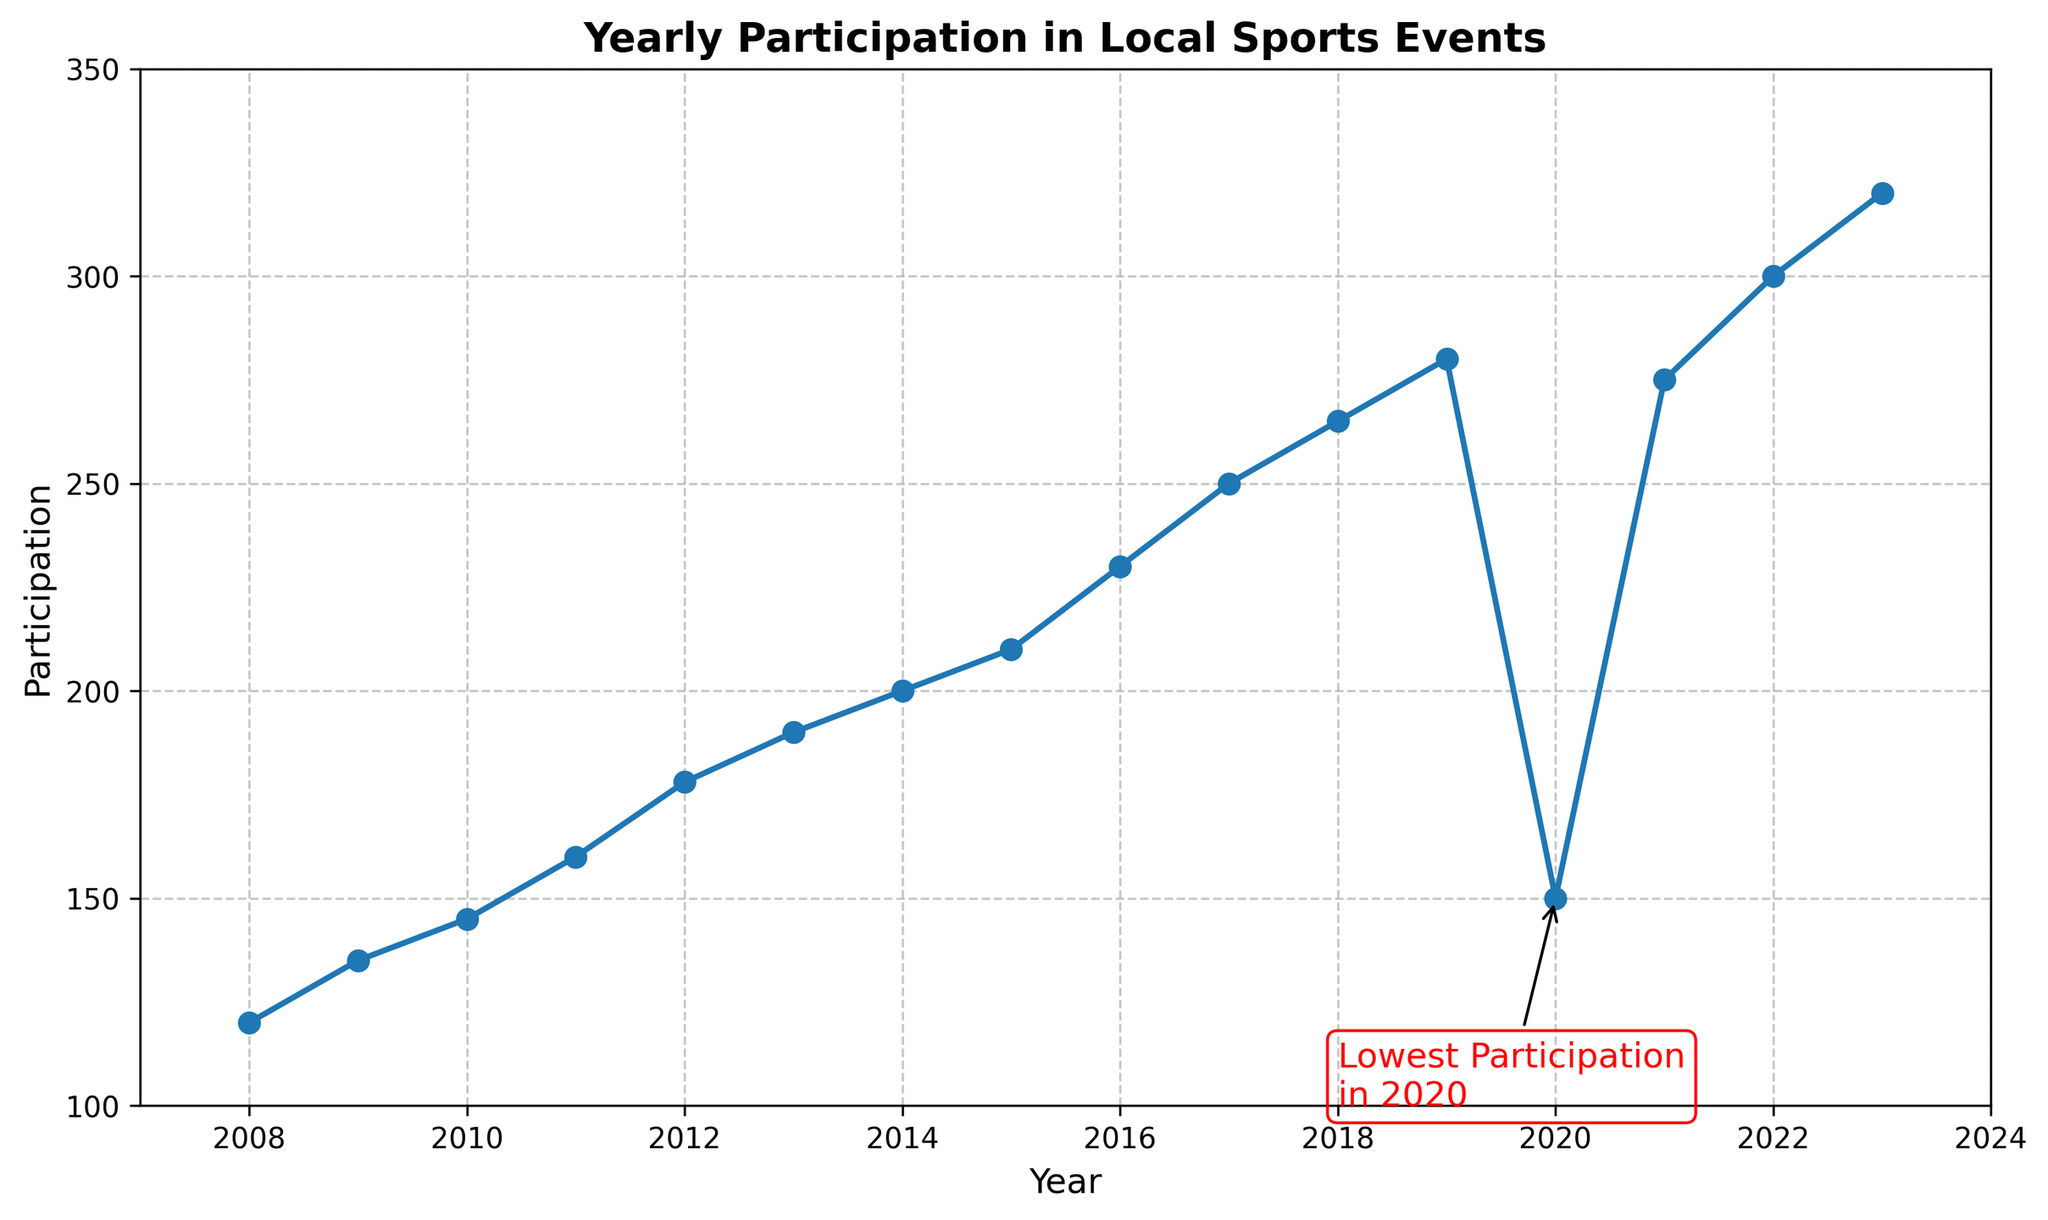What is the highest participation year? The highest value on the y-axis represents the participation number, which corresponds to the year on the x-axis. The highest participation is 320, occurring in 2023.
Answer: 2023 How did the participation trend from 2008 to 2015? Observing the line from 2008 to 2015, it generally shows an upward trend without any significant drops. The participation consistently increases each year.
Answer: Increasing Which year experienced the largest drop in participation? The largest drop is denoted by a sharp decline in the line chart. In 2020, participation decreased significantly before rebounding.
Answer: 2020 By how much did participation increase from 2016 to 2017? The values for the years 2016 and 2017 are 230 and 250 respectively. The increase can be calculated as 250 - 230 = 20.
Answer: 20 What is annotated in the graph? There is a red text annotation with an arrow pointing to 2020, noting the lowest participation.
Answer: Lowest Participation in 2020 Compare the participation in 2012 and 2018. Which year had higher participation? The participation in 2012 is 178, while in 2018 it is 265. Since 265 is greater than 178, 2018 had higher participation.
Answer: 2018 What is the average participation from 2010 to 2013? The values from 2010 to 2013 are 145, 160, 178, and 190. The average is (145 + 160 + 178 + 190) / 4 = 673 / 4 = 168.25.
Answer: 168.25 How many times did participation exceed 250? The participation values exceeding 250 are seen in the years 2018 (265), 2019 (280), 2021 (275), 2022 (300), and 2023 (320). This occurred 5 times.
Answer: 5 What is the difference between the highest and lowest participation values? The highest participation is 320 (in 2023) and the lowest is 120 (in 2008). The difference is 320 - 120 = 200.
Answer: 200 